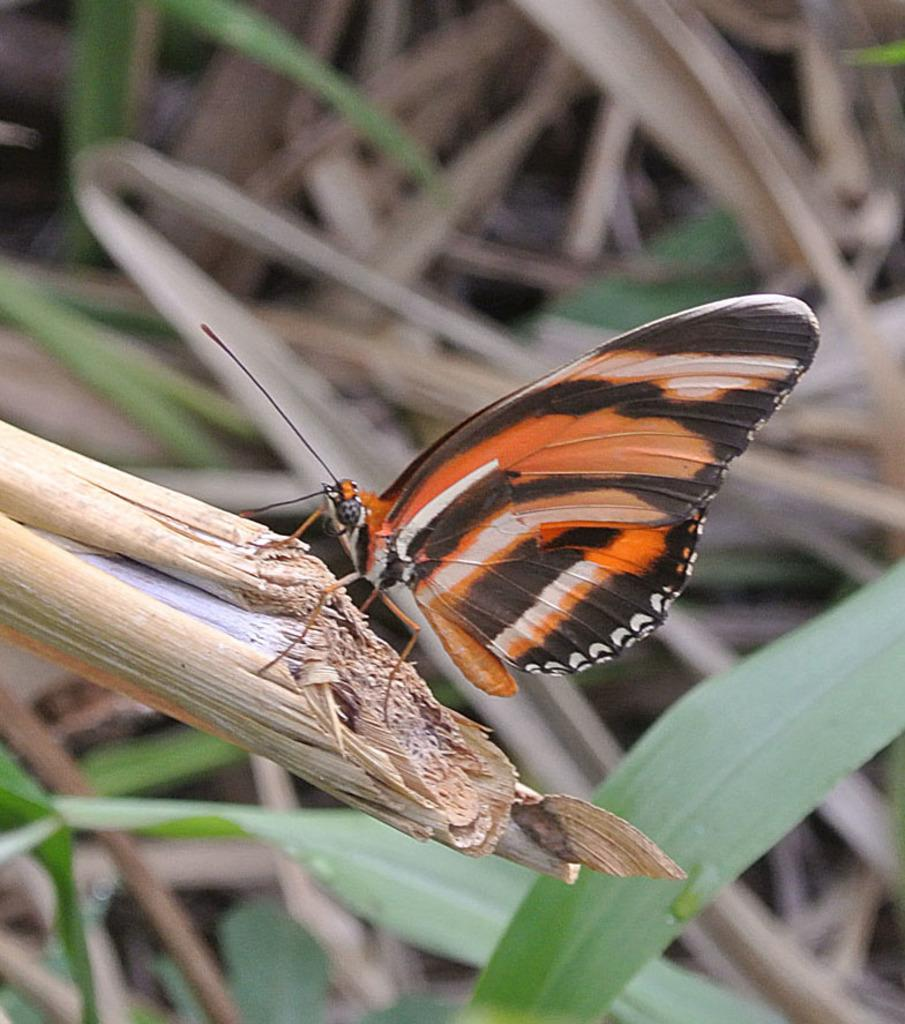What is the main subject of the image? There is a butterfly in the image. Where is the butterfly located? The butterfly is on a dried grass plant. What type of vegetation is present in the image? There are grass plants in the image, and some of them are dried. What is the weight of the train in the image? There is no train present in the image, so it's not possible to determine its weight. 